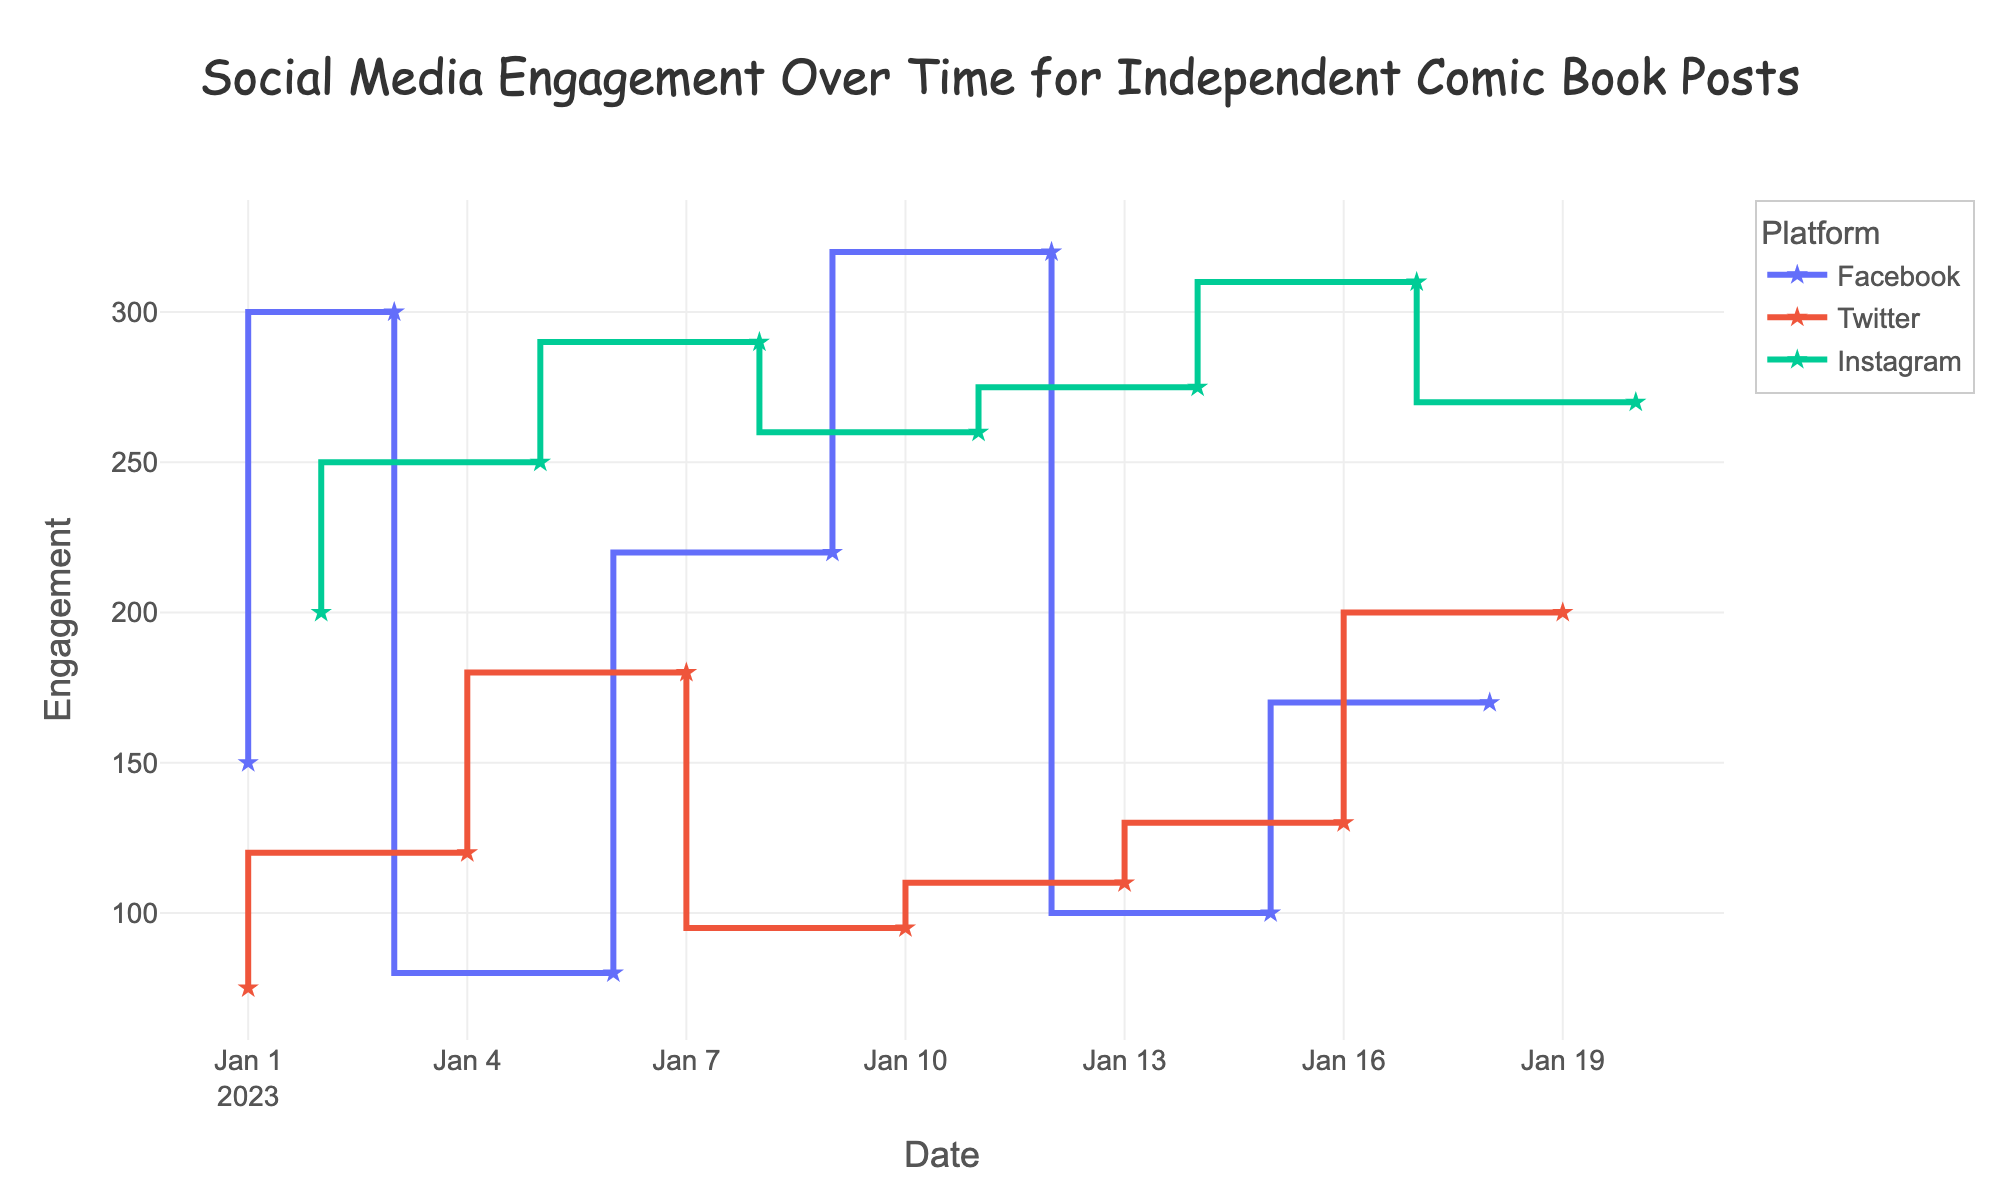Which platform had the highest engagement on January 3, 2023? Look at the point in the figure for January 3, 2023. Check which platform has the highest y-value on that date. Facebook has the highest engagement on January 3, 2023, with an engagement value of 300.
Answer: Facebook How many total engagement points did Instagram accumulate over the plotted period? Sum all engagement values for Instagram: 200 + 250 + 290 + 260 + 275 + 310 + 270. The total is 1855.
Answer: 1855 Which day had the highest engagement for an Instagram Reel? Identify the dates where the post type is 'Reel' for Instagram, then find which date has the highest engagement. January 17, 2023 has the highest engagement for an Instagram Reel with a value of 310.
Answer: January 17, 2023 What was the overall trend for Facebook post engagement over the period? Observe the engagement values for Facebook posts across the dates and describe the general direction (upward, downward, fluctuating). The overall trend for Facebook post engagement shows fluctuations with some peaks, ending higher than it started.
Answer: Fluctuating with upward tendency What was the engagement difference between Twitter links on January 1, 2023, and January 13, 2023? Compare the engagement values for Twitter links on the two dates: 75 on January 1 and 110 on January 13. Subtract the value on January 1 from the value on January 13. The difference is 110 - 75 = 35.
Answer: 35 On which date did Twitter post have the lowest engagement, and what was the value? Identify the point for each Twitter post and find the date with the lowest y-value. January 10, 2023, had the lowest engagement for a Twitter post with a value of 95.
Answer: January 10, 2023, 95 Which platform showed a steady increase in engagement for posts between January 5 and January 20? Examine the engagement values for all platforms between January 5 and January 20 to see if any of them increase consistently without significant drops. Instagram showed a steady increase in engagement within that period.
Answer: Instagram What is the median value of engagement for Facebook contributions? List Facebook engagement values: 150, 300, 80, 220, 320, 170, 100, sort them: 80, 100, 150, 170, 220, 300, 320. The median (middle value) is 170.
Answer: 170 What's the average engagement for Instagram posts on January 5 and January 20? Take the engagement values for Instagram posts on January 5 and January 20: 250 and 270. The average is (250 + 270) / 2 = 260.
Answer: 260 Between Facebook and Twitter, which platform had more instances of engagements above 200? Count occurrences where engagement values are above 200 for each platform. Facebook has instances: 300, 220, 320, 170, and Twitter has instances: 200, 180. Facebook has more instances with values above 200.
Answer: Facebook 